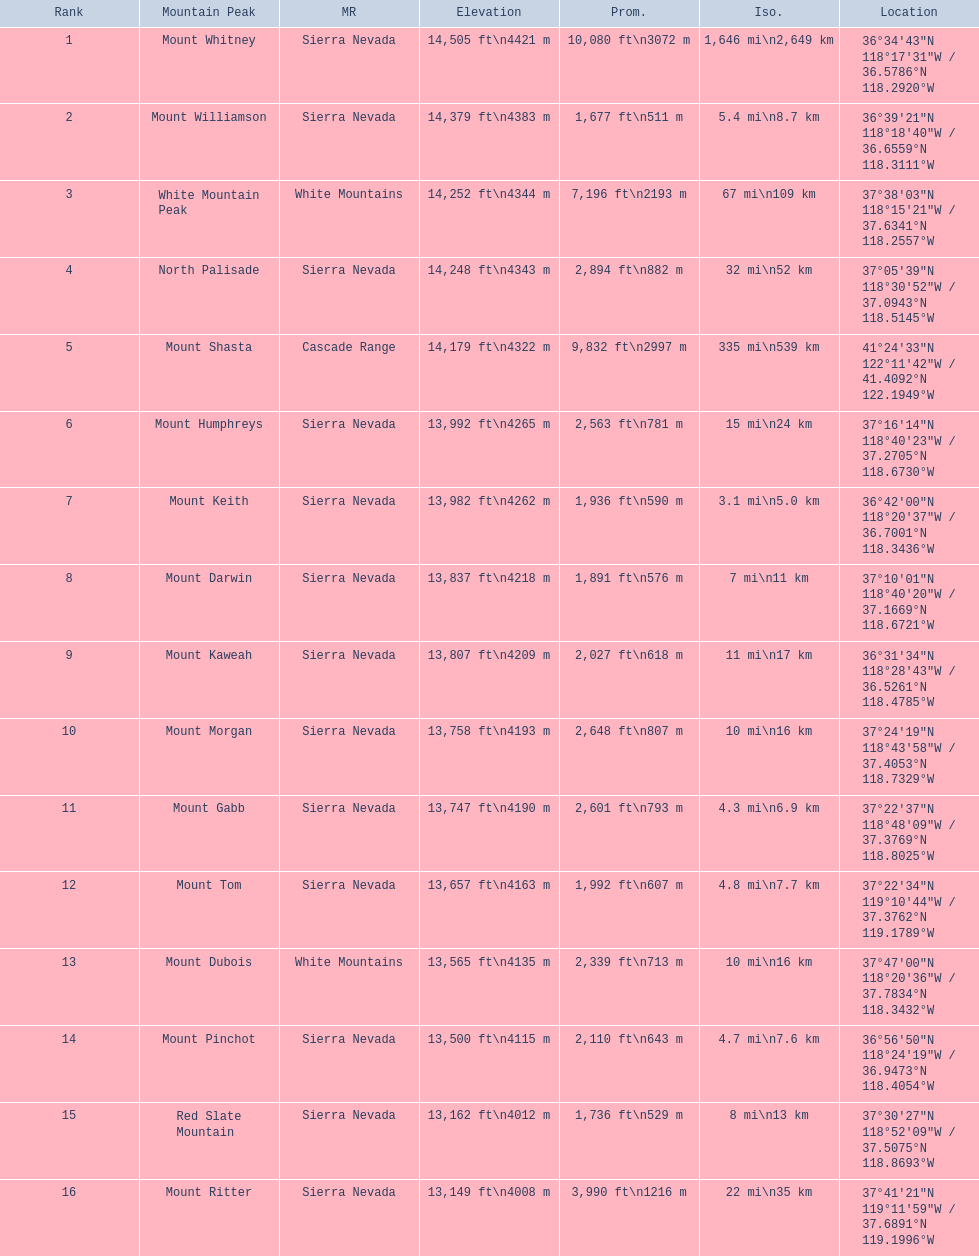What mountain peak is listed for the sierra nevada mountain range? Mount Whitney. What mountain peak has an elevation of 14,379ft? Mount Williamson. Which mountain is listed for the cascade range? Mount Shasta. 